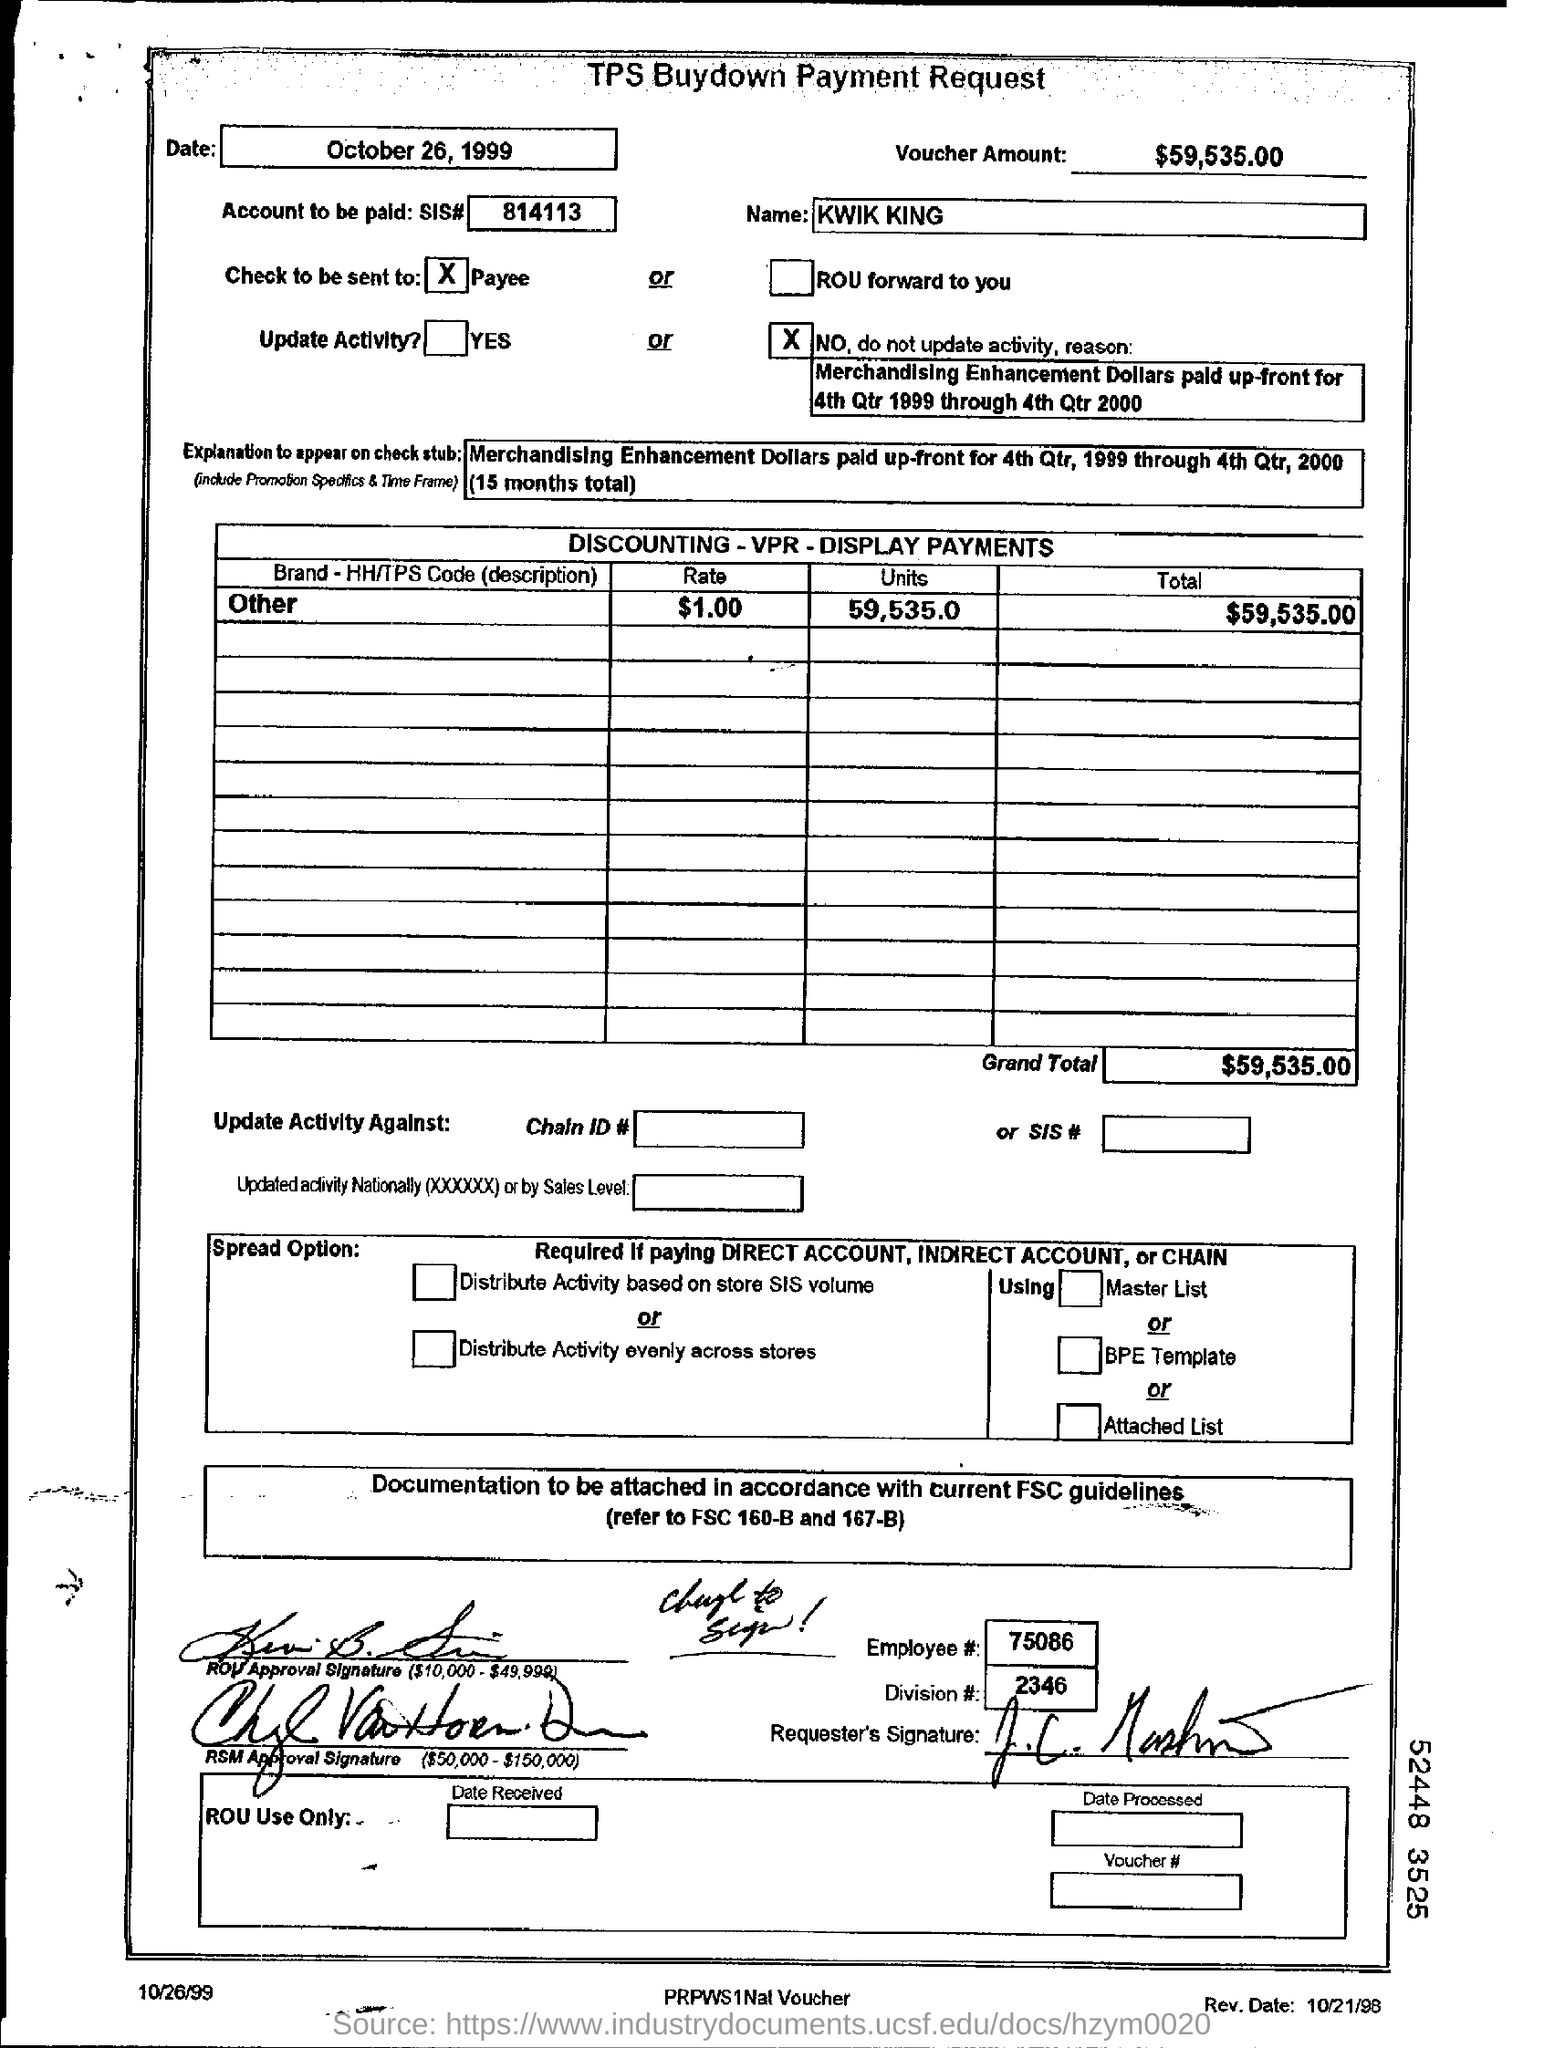how much rate for the brand - HH/TPS Code (description) for others? The document indicates that the rate for the brand listed under 'HH/TPS Code (description)' is $1.00 per unit, with a total amount being $59,535.00 for what appears to be a payment request related to merchandising enhancement. 